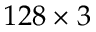<formula> <loc_0><loc_0><loc_500><loc_500>1 2 8 \times 3</formula> 